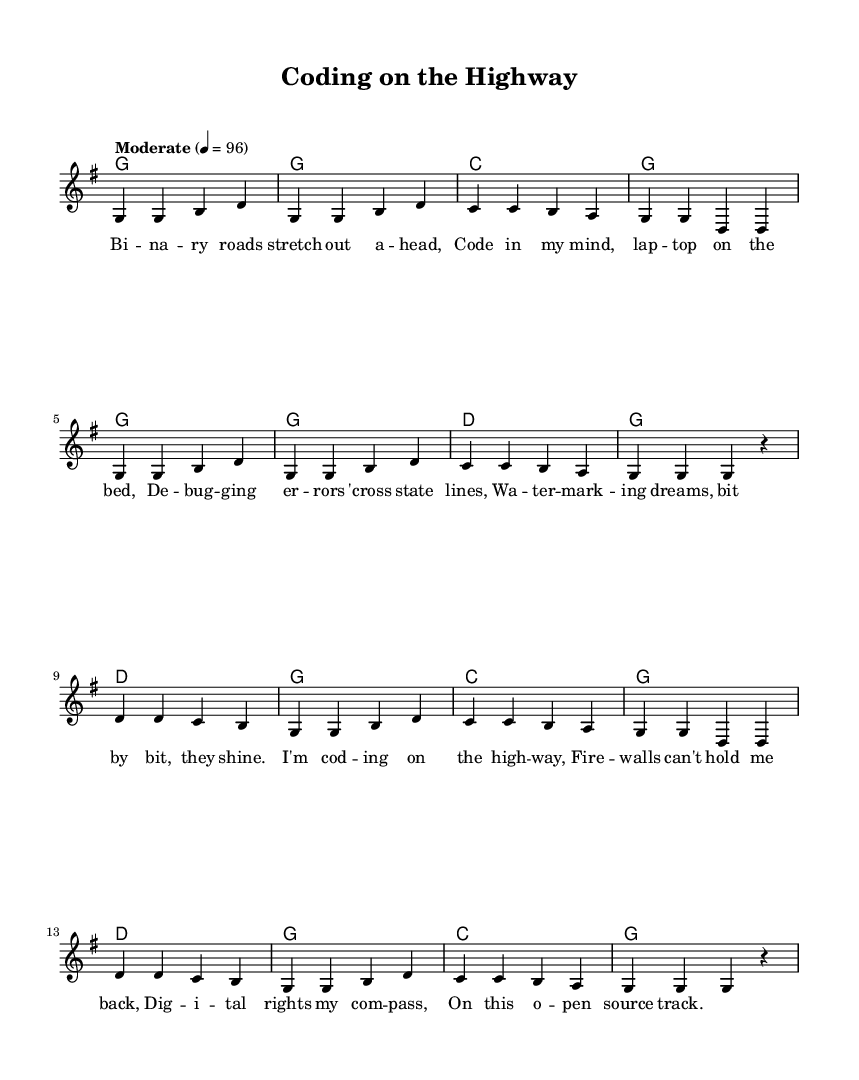What is the key signature of this music? The key signature is G major, which has one sharp (F#). This is indicated at the beginning of the staff.
Answer: G major What is the time signature of the music? The time signature is 4/4, as shown at the beginning of the score, which means there are four beats per measure and the quarter note gets one beat.
Answer: 4/4 What is the tempo marking for the piece? The tempo marking is "Moderate" with a speed of 96 beats per minute, indicated at the beginning of the score.
Answer: Moderate How many measures are in the verse? The verse consists of eight measures, as counted from the melody section. Counting all the measures listed under the verse indicates this total.
Answer: Eight measures What instrument is this sheet music written for? The sheet music is written for a piano, as indicated by the presence of chords and melody typically arranged for a piano score.
Answer: Piano What is the last lyric line of the chorus? The last lyric line of the chorus is "On this open source track," which is displayed under the melody notes of the chorus section.
Answer: On this open source track What type of content does this song's lyrics express? The lyrics express themes related to programming and technology, specifically referencing concepts like debugging, digital rights, and open source, all indicative of a programmer’s journey.
Answer: Programming and technology themes 